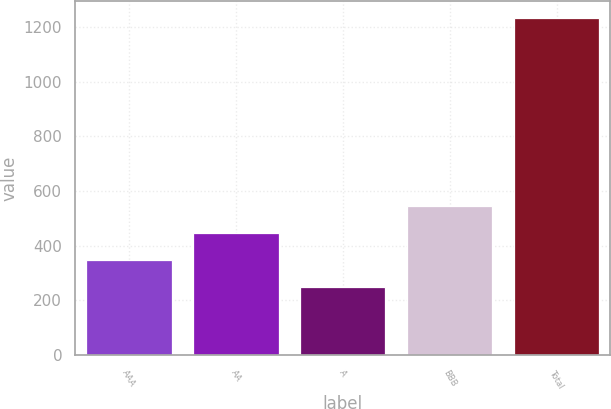Convert chart to OTSL. <chart><loc_0><loc_0><loc_500><loc_500><bar_chart><fcel>AAA<fcel>AA<fcel>A<fcel>BBB<fcel>Total<nl><fcel>347.3<fcel>445.6<fcel>249<fcel>543.9<fcel>1232<nl></chart> 